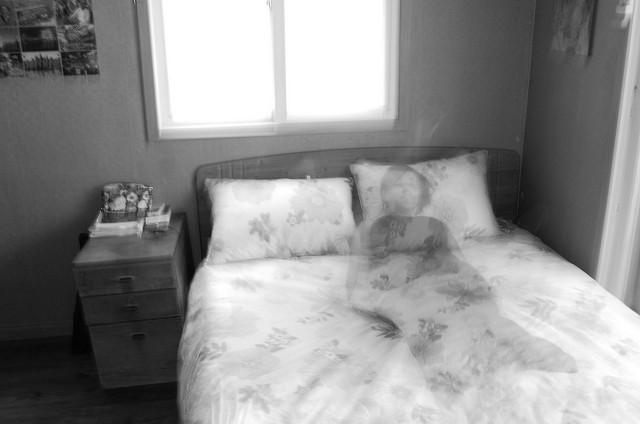The exposure makes the woman look like what? ghost 